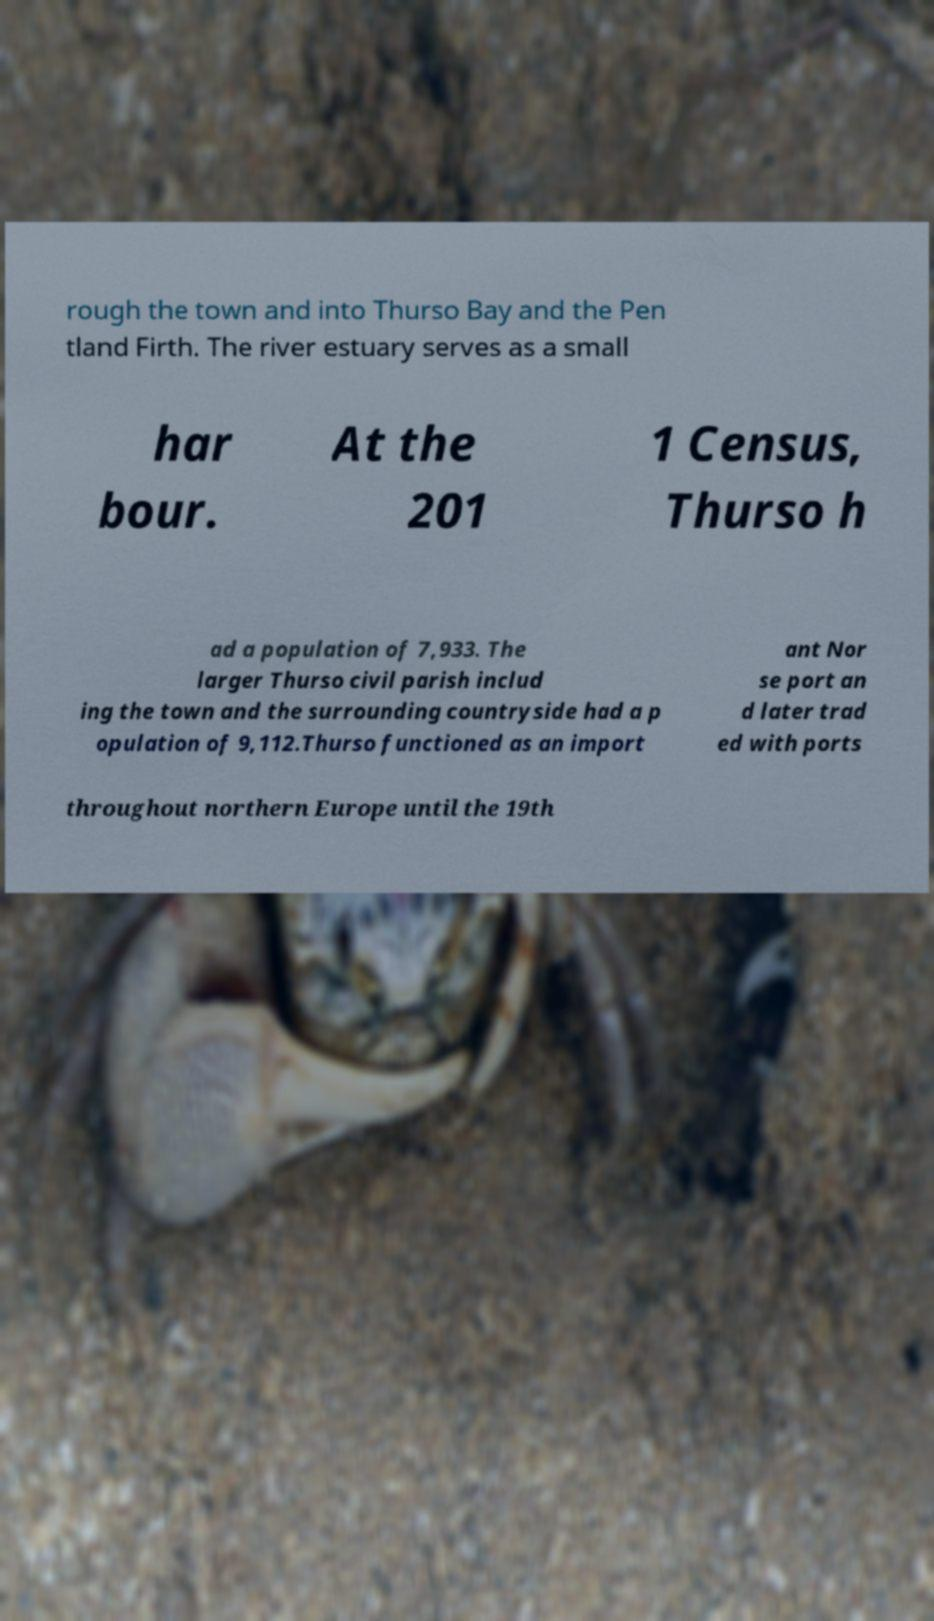Could you extract and type out the text from this image? rough the town and into Thurso Bay and the Pen tland Firth. The river estuary serves as a small har bour. At the 201 1 Census, Thurso h ad a population of 7,933. The larger Thurso civil parish includ ing the town and the surrounding countryside had a p opulation of 9,112.Thurso functioned as an import ant Nor se port an d later trad ed with ports throughout northern Europe until the 19th 